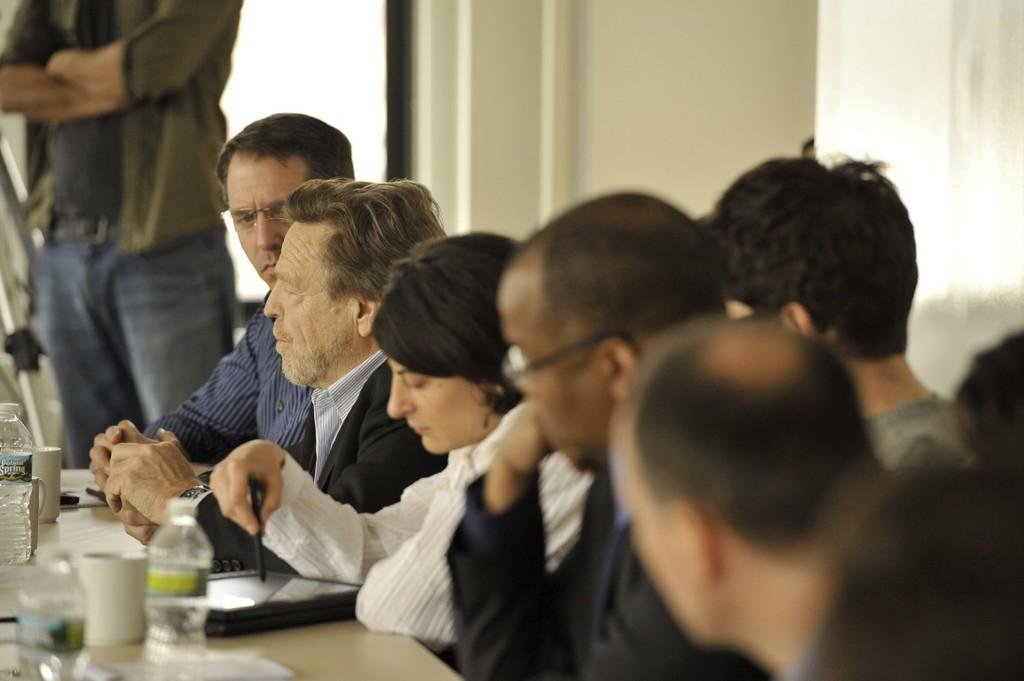What are the people in the image doing? There is a group of persons sitting in front of a table. What can be seen on the table? The table has objects on it. Is there anyone else in the image besides the group of persons sitting at the table? Yes, there is a person standing in the left corner of the image. What type of fowl can be seen flying over the table in the image? There is no fowl visible in the image; it only shows a group of persons sitting at a table and a person standing in the left corner. What riddle is being solved by the group of persons in the image? There is no riddle being solved in the image; it only shows a group of persons sitting at a table and a person standing in the left corner. 